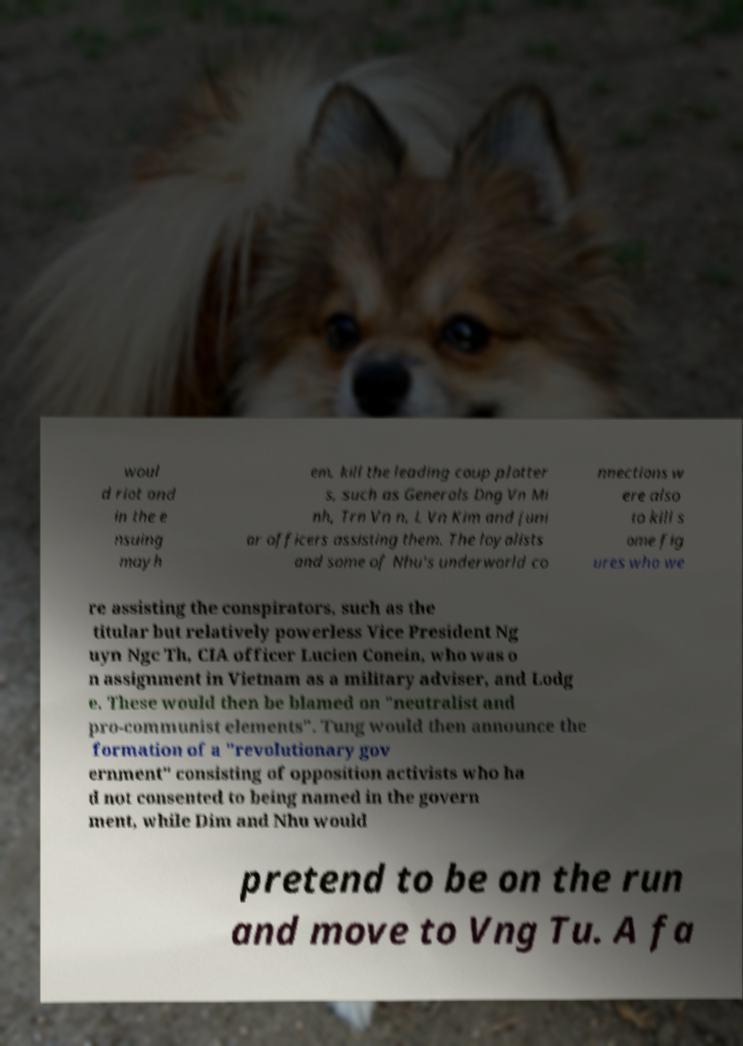Could you assist in decoding the text presented in this image and type it out clearly? woul d riot and in the e nsuing mayh em, kill the leading coup plotter s, such as Generals Dng Vn Mi nh, Trn Vn n, L Vn Kim and juni or officers assisting them. The loyalists and some of Nhu's underworld co nnections w ere also to kill s ome fig ures who we re assisting the conspirators, such as the titular but relatively powerless Vice President Ng uyn Ngc Th, CIA officer Lucien Conein, who was o n assignment in Vietnam as a military adviser, and Lodg e. These would then be blamed on "neutralist and pro-communist elements". Tung would then announce the formation of a "revolutionary gov ernment" consisting of opposition activists who ha d not consented to being named in the govern ment, while Dim and Nhu would pretend to be on the run and move to Vng Tu. A fa 